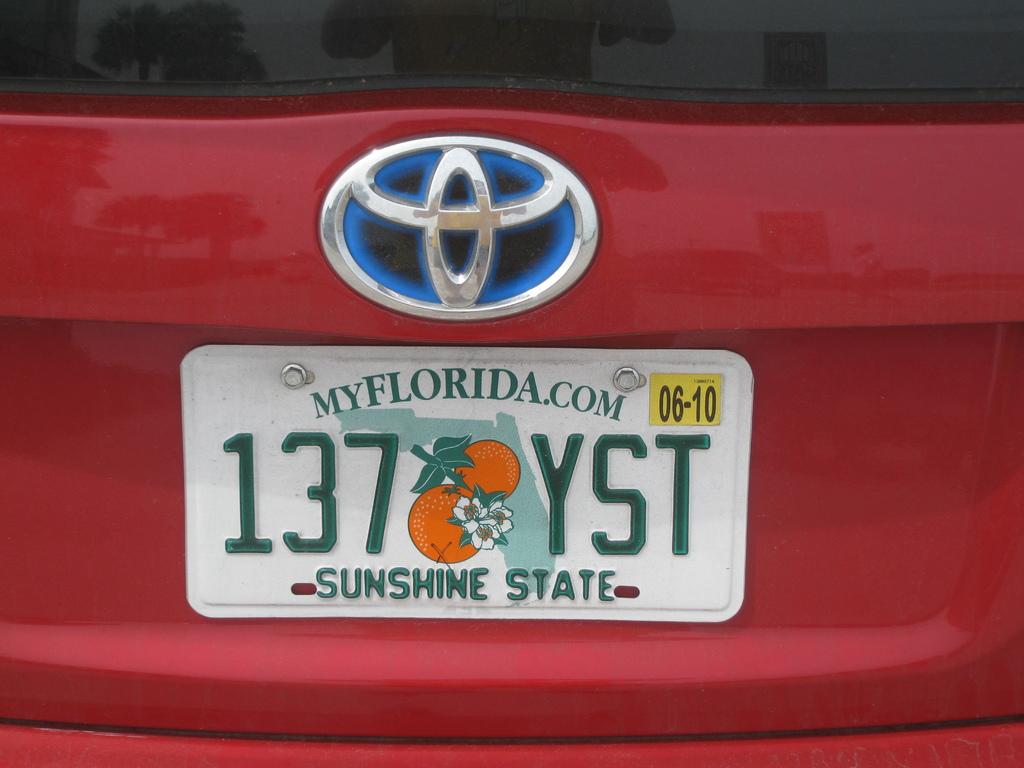What´s the state of this license plate?
Your response must be concise. Florida. 